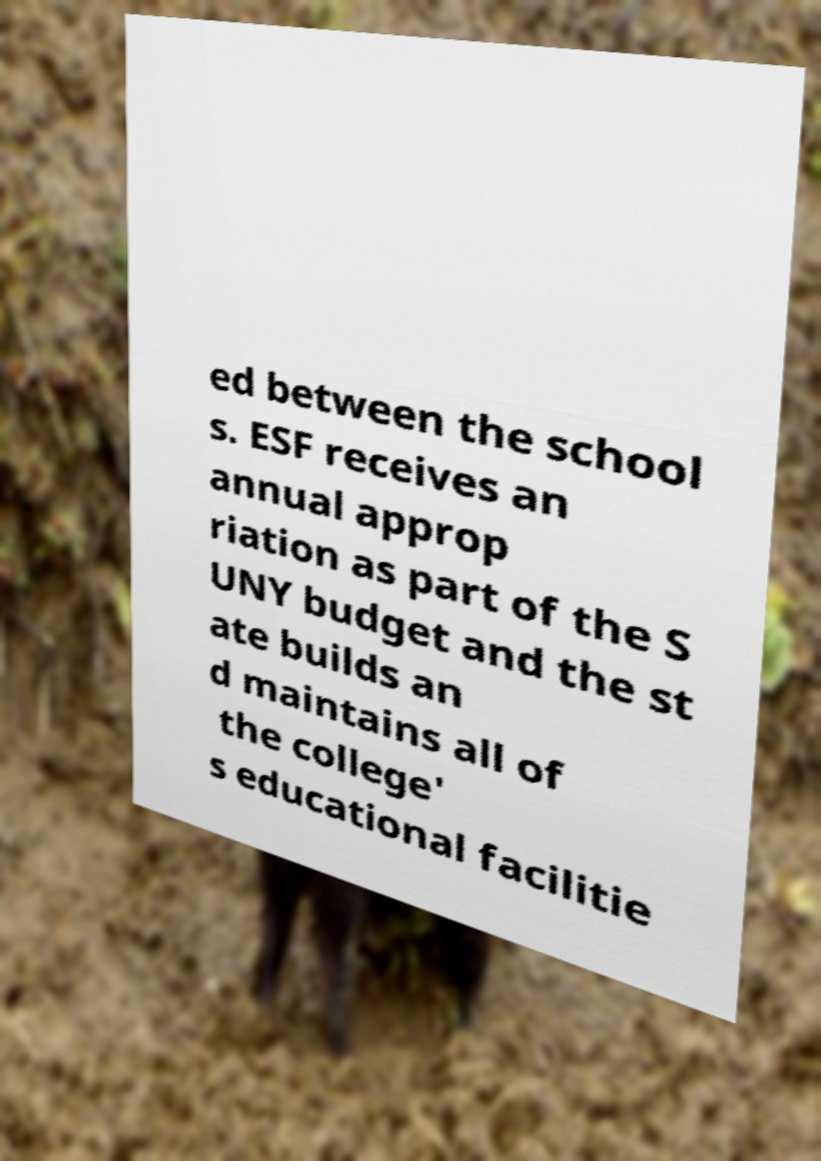Could you extract and type out the text from this image? ed between the school s. ESF receives an annual approp riation as part of the S UNY budget and the st ate builds an d maintains all of the college' s educational facilitie 